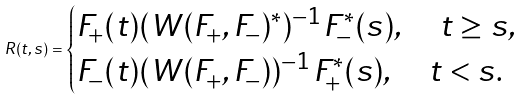<formula> <loc_0><loc_0><loc_500><loc_500>R ( t , s ) = \begin{cases} F _ { + } ( t ) ( W ( F _ { + } , F _ { - } ) ^ { * } ) ^ { - 1 } F _ { - } ^ { * } ( s ) , \quad t \geq s , \\ F _ { - } ( t ) ( W ( F _ { + } , F _ { - } ) ) ^ { - 1 } F _ { + } ^ { * } ( s ) , \quad t < s . \end{cases}</formula> 